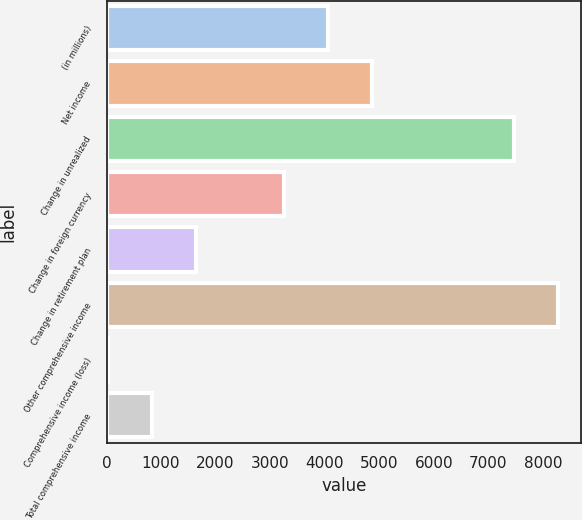Convert chart to OTSL. <chart><loc_0><loc_0><loc_500><loc_500><bar_chart><fcel>(in millions)<fcel>Net income<fcel>Change in unrealized<fcel>Change in foreign currency<fcel>Change in retirement plan<fcel>Other comprehensive income<fcel>Comprehensive income (loss)<fcel>Total comprehensive income<nl><fcel>4053<fcel>4859.6<fcel>7477.2<fcel>3246.4<fcel>1633.2<fcel>8283.8<fcel>20<fcel>826.6<nl></chart> 